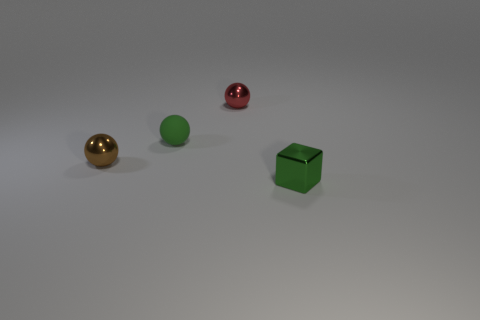Subtract 2 balls. How many balls are left? 1 Add 3 green metallic blocks. How many objects exist? 7 Subtract all tiny green balls. How many balls are left? 2 Subtract all green spheres. How many spheres are left? 2 Subtract 0 purple spheres. How many objects are left? 4 Subtract all balls. How many objects are left? 1 Subtract all cyan spheres. Subtract all red cubes. How many spheres are left? 3 Subtract all green blocks. How many brown balls are left? 1 Subtract all tiny blue blocks. Subtract all small brown things. How many objects are left? 3 Add 1 brown metal objects. How many brown metal objects are left? 2 